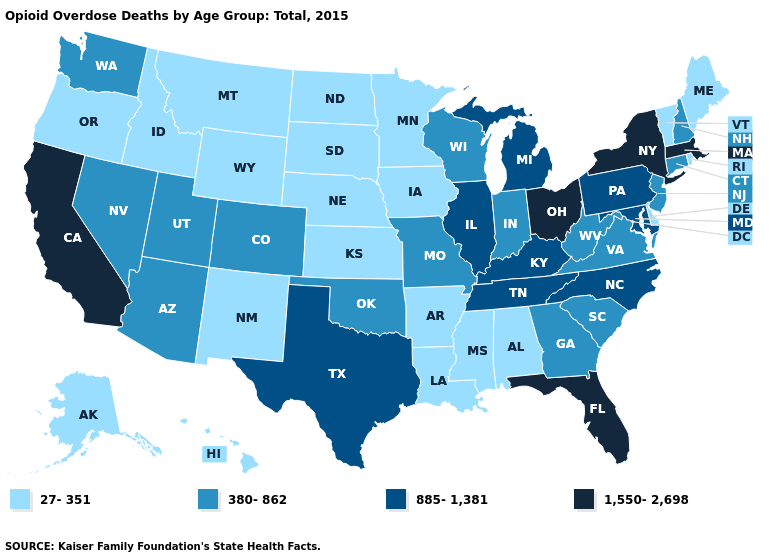Among the states that border North Carolina , does Georgia have the lowest value?
Quick response, please. Yes. What is the value of Ohio?
Give a very brief answer. 1,550-2,698. What is the value of North Carolina?
Be succinct. 885-1,381. Among the states that border Iowa , which have the lowest value?
Quick response, please. Minnesota, Nebraska, South Dakota. How many symbols are there in the legend?
Be succinct. 4. Name the states that have a value in the range 380-862?
Short answer required. Arizona, Colorado, Connecticut, Georgia, Indiana, Missouri, Nevada, New Hampshire, New Jersey, Oklahoma, South Carolina, Utah, Virginia, Washington, West Virginia, Wisconsin. Does the first symbol in the legend represent the smallest category?
Keep it brief. Yes. Which states hav the highest value in the MidWest?
Concise answer only. Ohio. What is the highest value in the USA?
Quick response, please. 1,550-2,698. Does the first symbol in the legend represent the smallest category?
Quick response, please. Yes. Does Arizona have the highest value in the West?
Be succinct. No. What is the lowest value in the West?
Give a very brief answer. 27-351. Does New Jersey have the lowest value in the USA?
Quick response, please. No. What is the lowest value in states that border Ohio?
Give a very brief answer. 380-862. 